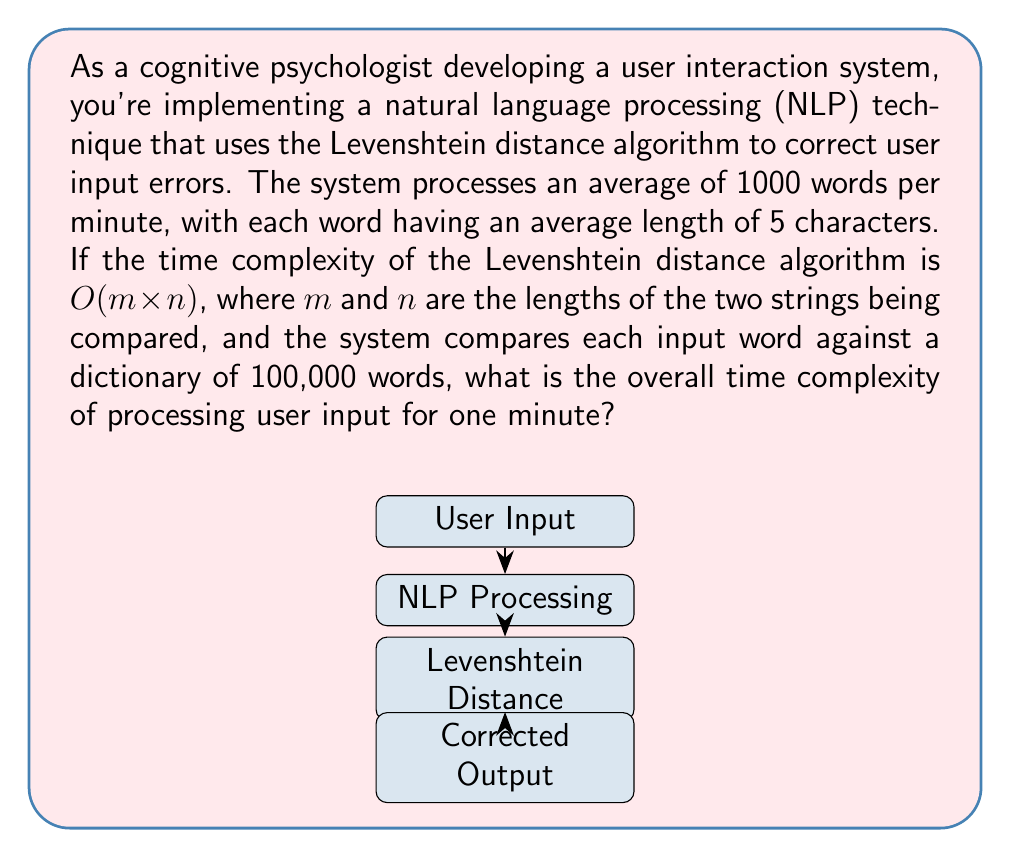Can you solve this math problem? Let's break this down step-by-step:

1) First, we need to calculate the number of comparisons made per word:
   - Each input word is compared against 100,000 dictionary words
   - Number of comparisons per word = 100,000

2) Now, let's consider the time complexity of each comparison:
   - The Levenshtein distance algorithm has a time complexity of $O(m \times n)$
   - $m$ and $n$ are both 5 (average word length)
   - So, each comparison has a complexity of $O(5 \times 5) = O(25) = O(1)$ (constant time)

3) For each word processed:
   - Time complexity = $O(100,000 \times 1) = O(100,000)$

4) Number of words processed per minute:
   - Words per minute = 1000

5) Total time complexity for one minute:
   - $O(1000 \times 100,000) = O(100,000,000) = O(10^8)$

Therefore, the overall time complexity for processing user input for one minute is $O(10^8)$.
Answer: $O(10^8)$ 